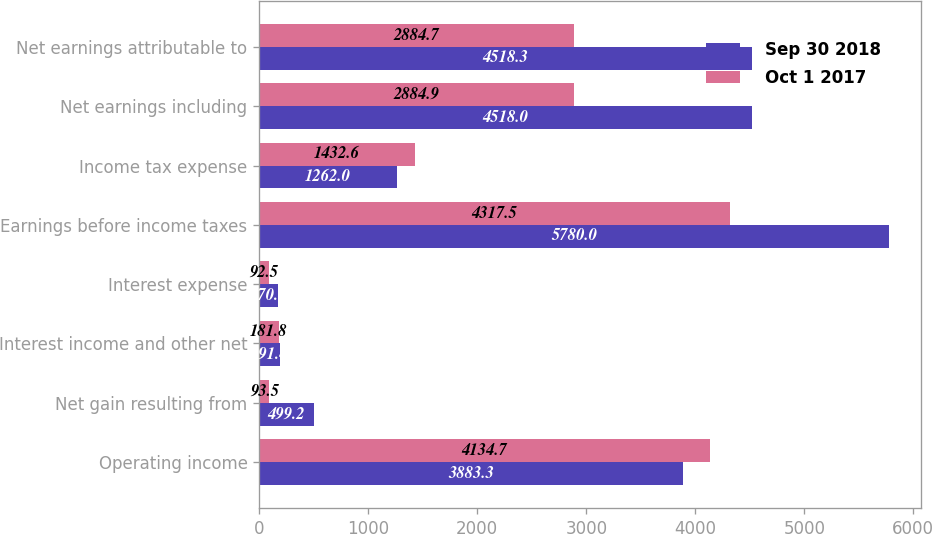Convert chart. <chart><loc_0><loc_0><loc_500><loc_500><stacked_bar_chart><ecel><fcel>Operating income<fcel>Net gain resulting from<fcel>Interest income and other net<fcel>Interest expense<fcel>Earnings before income taxes<fcel>Income tax expense<fcel>Net earnings including<fcel>Net earnings attributable to<nl><fcel>Sep 30 2018<fcel>3883.3<fcel>499.2<fcel>191.4<fcel>170.3<fcel>5780<fcel>1262<fcel>4518<fcel>4518.3<nl><fcel>Oct 1 2017<fcel>4134.7<fcel>93.5<fcel>181.8<fcel>92.5<fcel>4317.5<fcel>1432.6<fcel>2884.9<fcel>2884.7<nl></chart> 